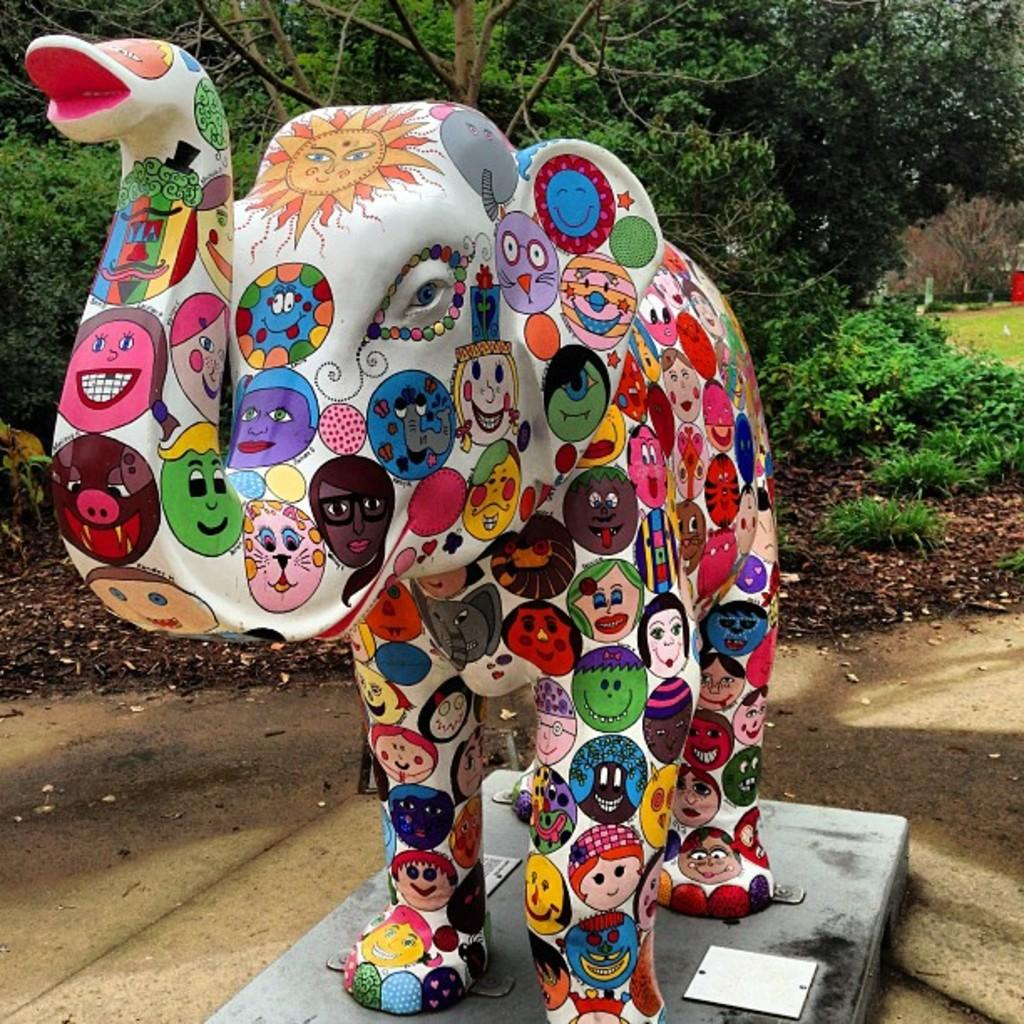What is the main subject of the image? There is a statue of an elephant in the image. What is unique about the statue? The statue has a painting on it. What can be seen in the background of the image? There are trees and plants in the background of the image. How does the statue of the elephant capture the attention of the campers in the image? There is no mention of campers or a camp in the image, so it cannot be determined how the statue captures their attention. 